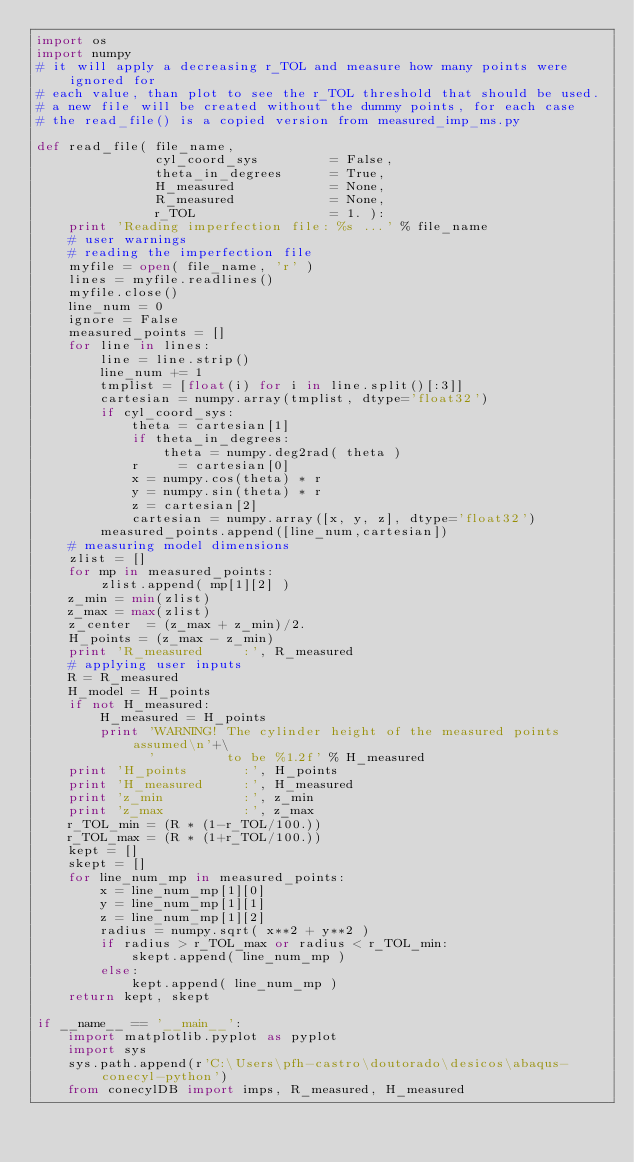<code> <loc_0><loc_0><loc_500><loc_500><_Python_>import os
import numpy
# it will apply a decreasing r_TOL and measure how many points were ignored for
# each value, than plot to see the r_TOL threshold that should be used.
# a new file will be created without the dummy points, for each case
# the read_file() is a copied version from measured_imp_ms.py

def read_file( file_name,
               cyl_coord_sys         = False,
               theta_in_degrees      = True,
               H_measured            = None,
               R_measured            = None,
               r_TOL                 = 1. ):
    print 'Reading imperfection file: %s ...' % file_name
    # user warnings
    # reading the imperfection file
    myfile = open( file_name, 'r' )
    lines = myfile.readlines()
    myfile.close()
    line_num = 0
    ignore = False
    measured_points = []
    for line in lines:
        line = line.strip()
        line_num += 1
        tmplist = [float(i) for i in line.split()[:3]]
        cartesian = numpy.array(tmplist, dtype='float32')
        if cyl_coord_sys:
            theta = cartesian[1]
            if theta_in_degrees:
                theta = numpy.deg2rad( theta )
            r     = cartesian[0]
            x = numpy.cos(theta) * r
            y = numpy.sin(theta) * r
            z = cartesian[2]
            cartesian = numpy.array([x, y, z], dtype='float32')
        measured_points.append([line_num,cartesian])
    # measuring model dimensions
    zlist = []
    for mp in measured_points:
        zlist.append( mp[1][2] )
    z_min = min(zlist)
    z_max = max(zlist)
    z_center  = (z_max + z_min)/2.
    H_points = (z_max - z_min)
    print 'R_measured     :', R_measured
    # applying user inputs
    R = R_measured
    H_model = H_points
    if not H_measured:
        H_measured = H_points
        print 'WARNING! The cylinder height of the measured points assumed\n'+\
              '         to be %1.2f' % H_measured
    print 'H_points       :', H_points
    print 'H_measured     :', H_measured
    print 'z_min          :', z_min
    print 'z_max          :', z_max
    r_TOL_min = (R * (1-r_TOL/100.))
    r_TOL_max = (R * (1+r_TOL/100.))
    kept = []
    skept = []
    for line_num_mp in measured_points:
        x = line_num_mp[1][0]
        y = line_num_mp[1][1]
        z = line_num_mp[1][2]
        radius = numpy.sqrt( x**2 + y**2 )
        if radius > r_TOL_max or radius < r_TOL_min:
            skept.append( line_num_mp )
        else:
            kept.append( line_num_mp )
    return kept, skept

if __name__ == '__main__':
    import matplotlib.pyplot as pyplot
    import sys
    sys.path.append(r'C:\Users\pfh-castro\doutorado\desicos\abaqus-conecyl-python')
    from conecylDB import imps, R_measured, H_measured</code> 